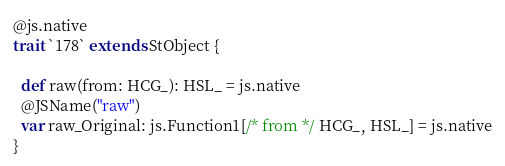Convert code to text. <code><loc_0><loc_0><loc_500><loc_500><_Scala_>
@js.native
trait `178` extends StObject {
  
  def raw(from: HCG_): HSL_ = js.native
  @JSName("raw")
  var raw_Original: js.Function1[/* from */ HCG_, HSL_] = js.native
}
</code> 